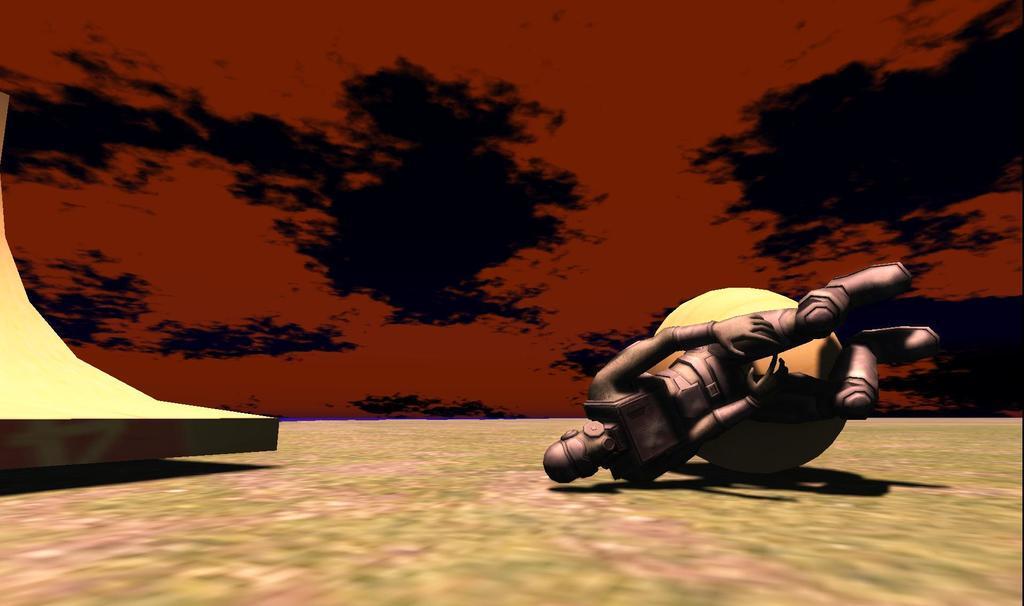Describe this image in one or two sentences. This is an animated image, it looks like a robot and a round shaped object. On the left side of the robot there is another object and it looks like a wall. 